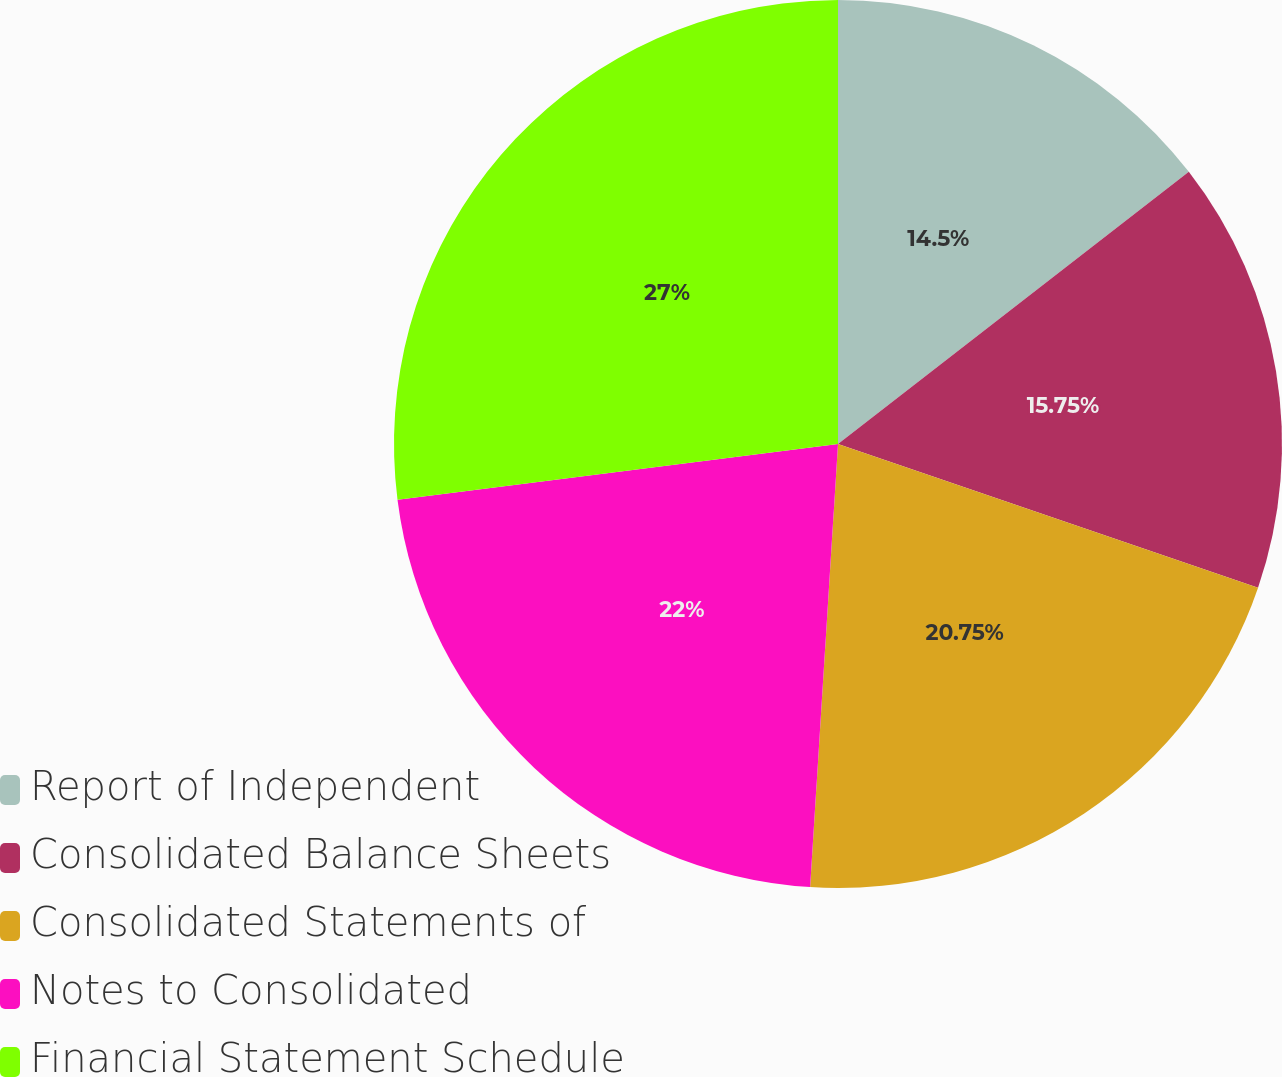<chart> <loc_0><loc_0><loc_500><loc_500><pie_chart><fcel>Report of Independent<fcel>Consolidated Balance Sheets<fcel>Consolidated Statements of<fcel>Notes to Consolidated<fcel>Financial Statement Schedule<nl><fcel>14.5%<fcel>15.75%<fcel>20.75%<fcel>22.0%<fcel>27.0%<nl></chart> 